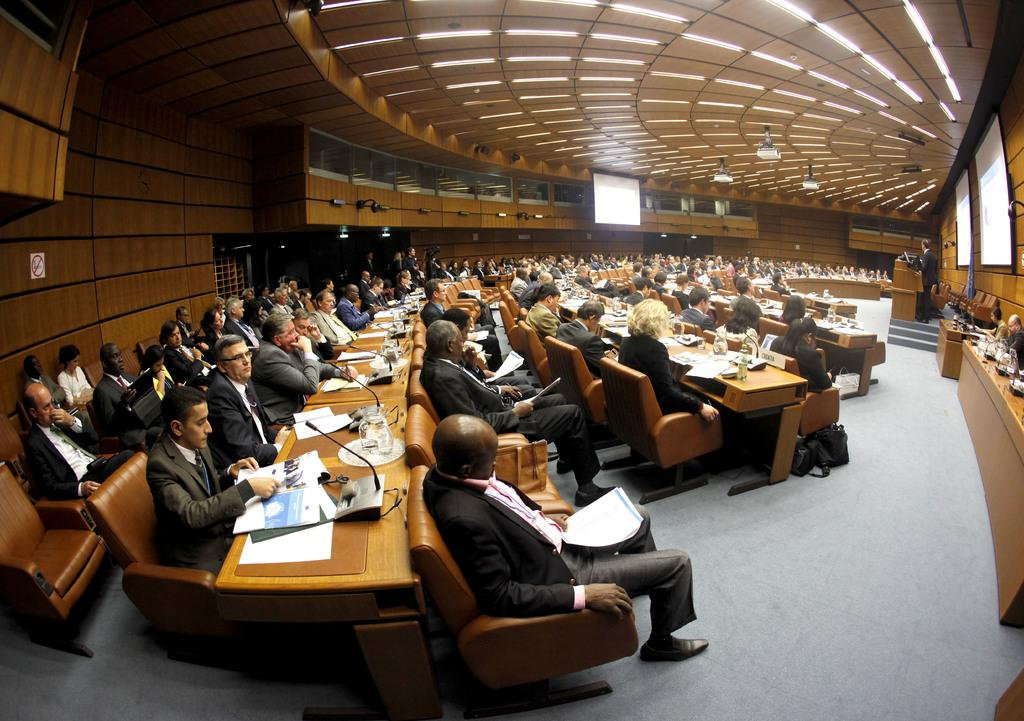What are the people in the image doing? The people in the image are sitting in chairs. What is in front of the group of people? There is a table in front of the group of people. What can be seen on the table? There are objects on the table. Is there anyone standing in the image? Yes, there is a person standing in the right corner of the image. What type of shoe is on the table in the image? There is no shoe present on the table in the image. How many dolls are sitting with the group of people in the image? There are no dolls present in the image; it features a group of people sitting in chairs. 